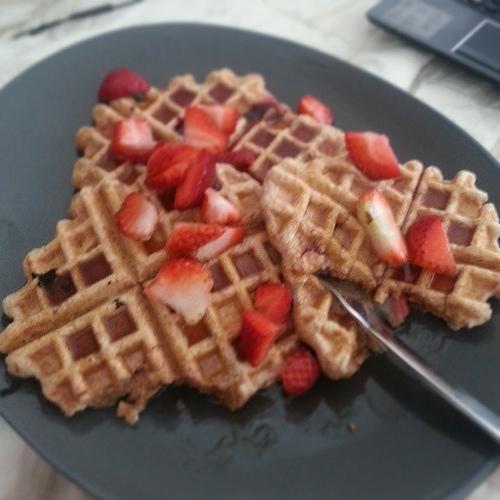How many plates are there?
Give a very brief answer. 1. 